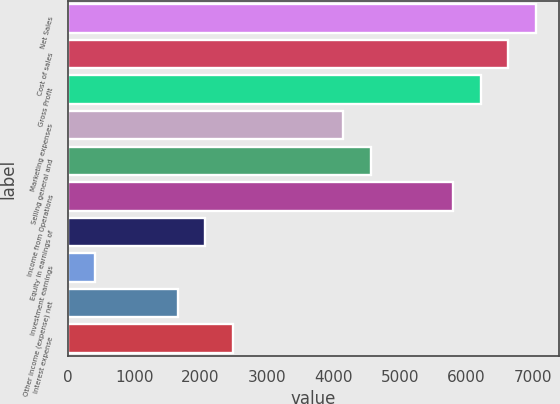Convert chart to OTSL. <chart><loc_0><loc_0><loc_500><loc_500><bar_chart><fcel>Net Sales<fcel>Cost of sales<fcel>Gross Profit<fcel>Marketing expenses<fcel>Selling general and<fcel>Income from Operations<fcel>Equity in earnings of<fcel>Investment earnings<fcel>Other income (expense) net<fcel>Interest expense<nl><fcel>7047.37<fcel>6632.87<fcel>6218.37<fcel>4145.87<fcel>4560.37<fcel>5803.87<fcel>2073.37<fcel>415.37<fcel>1658.87<fcel>2487.87<nl></chart> 